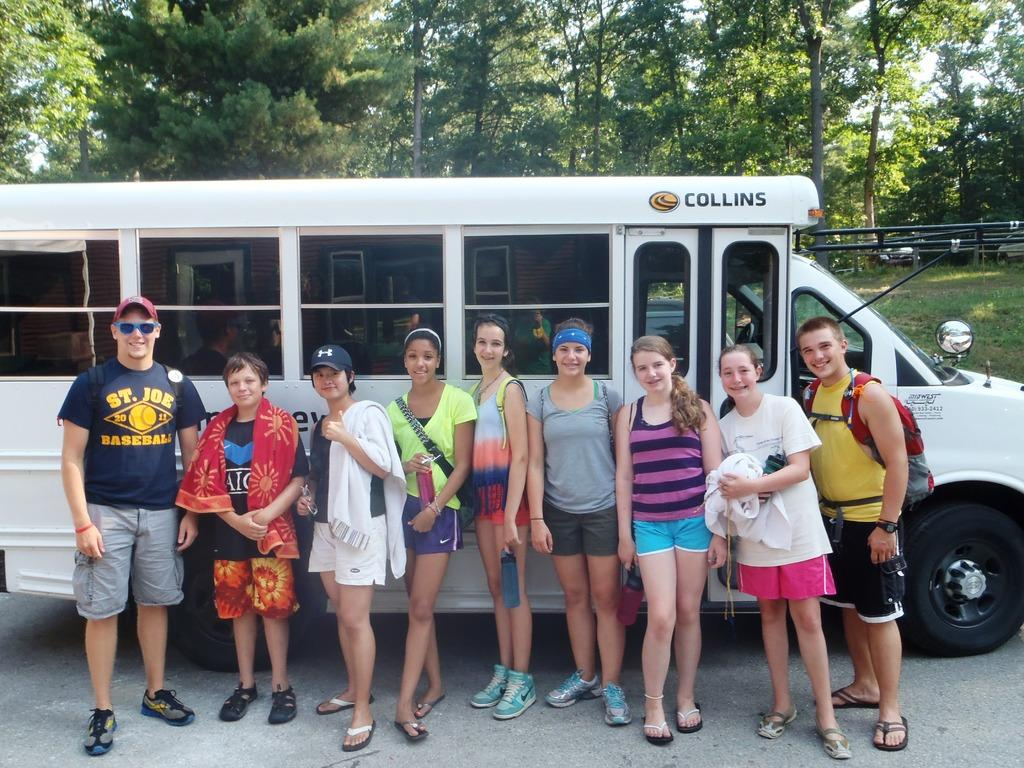What is the main subject of the image? The main subject of the image is a group of people on the road. What are the people doing in the image? The people are standing beside a truck. What can be seen in the background of the image? There is a fence, grass, plants, a group of trees, and the sky visible in the image. What type of fork is being used by the people in the image? There is no fork present in the image. What type of trade are the people engaged in while standing beside the truck? The image does not provide any information about the people's trade or occupation. 